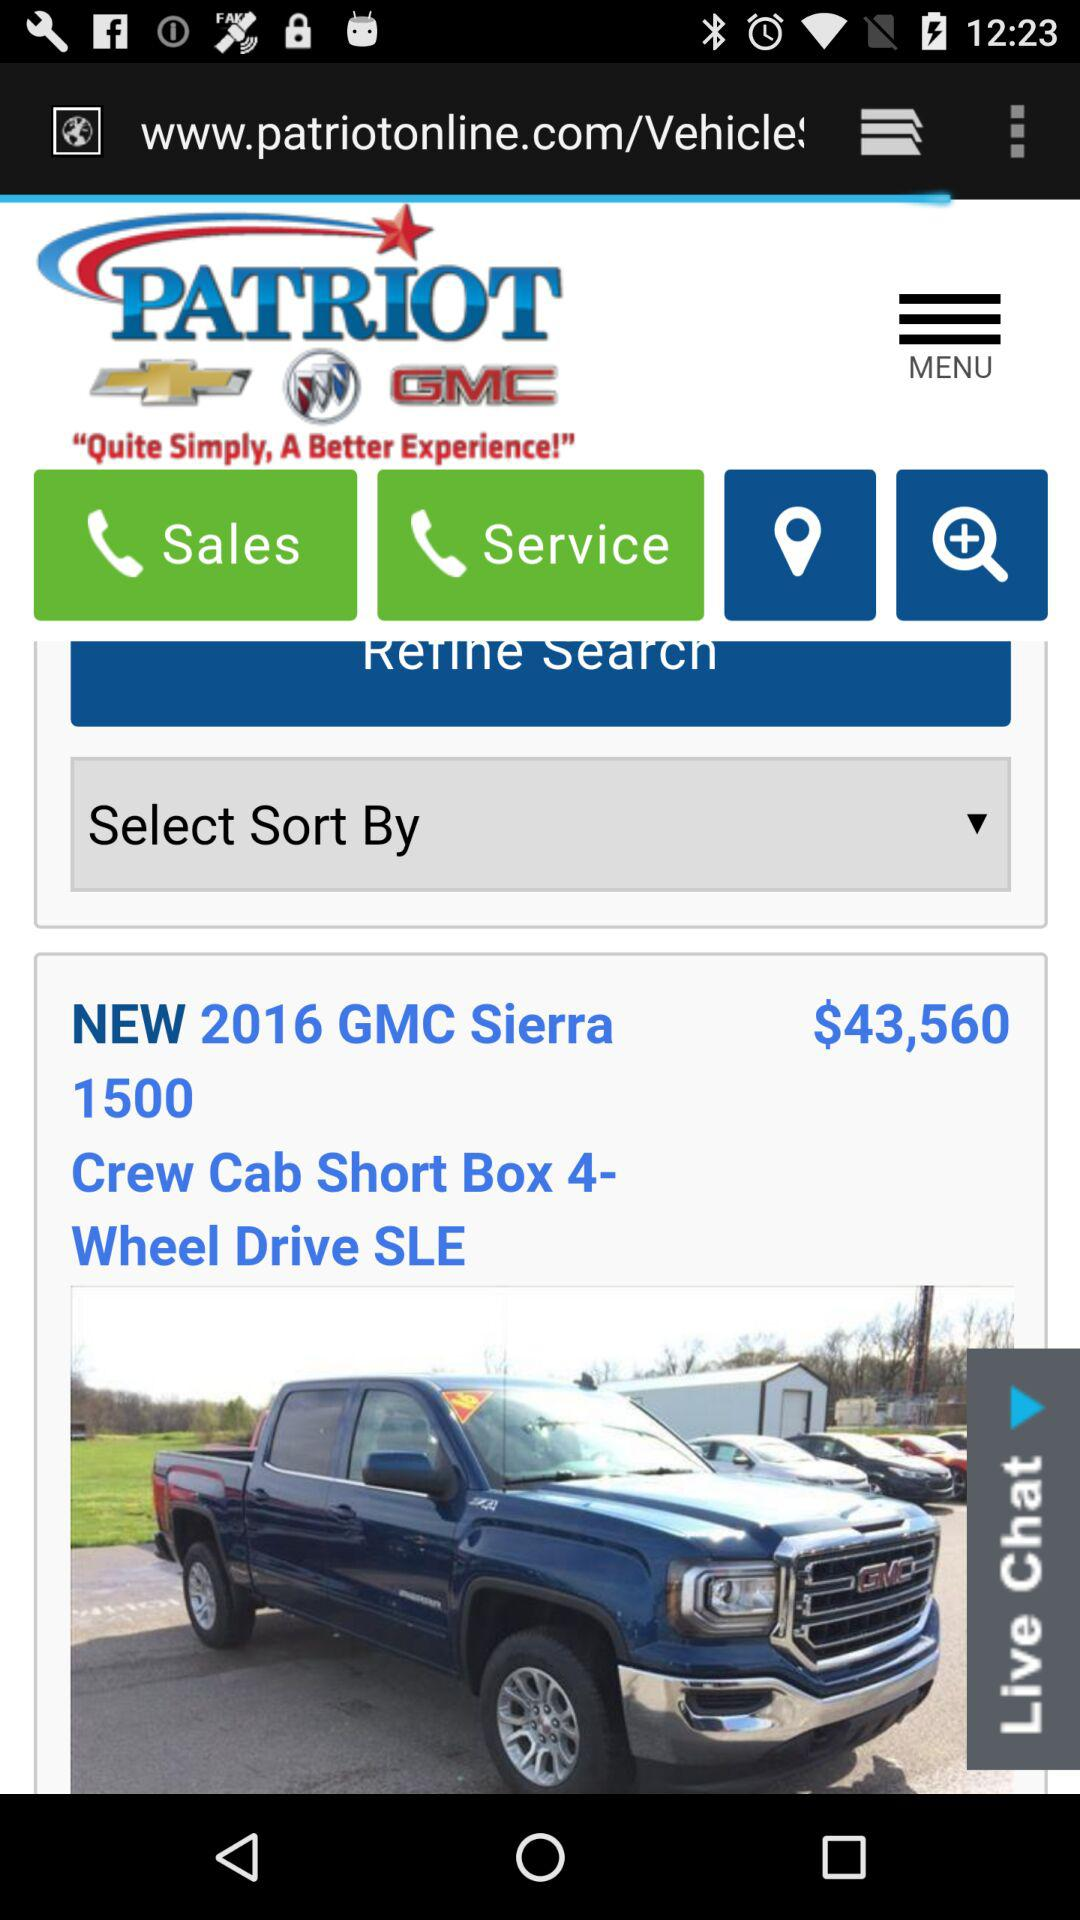What is the price of the vehicle?
Answer the question using a single word or phrase. $43,560 